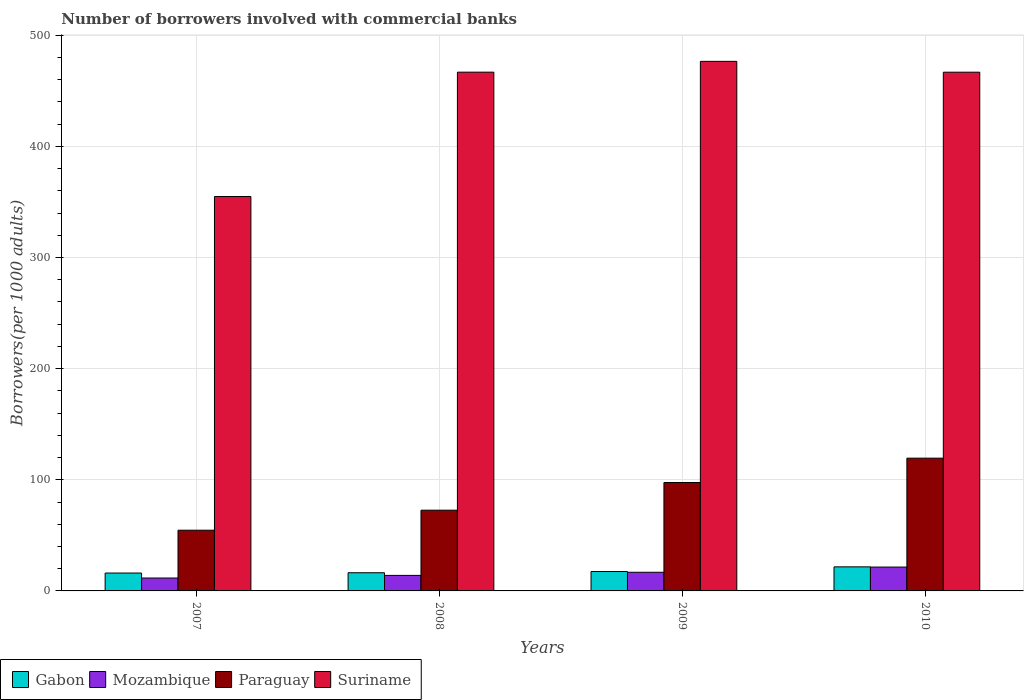How many different coloured bars are there?
Your answer should be compact. 4. Are the number of bars per tick equal to the number of legend labels?
Offer a terse response. Yes. Are the number of bars on each tick of the X-axis equal?
Keep it short and to the point. Yes. How many bars are there on the 4th tick from the right?
Ensure brevity in your answer.  4. What is the label of the 2nd group of bars from the left?
Provide a succinct answer. 2008. In how many cases, is the number of bars for a given year not equal to the number of legend labels?
Offer a terse response. 0. What is the number of borrowers involved with commercial banks in Mozambique in 2010?
Provide a short and direct response. 21.47. Across all years, what is the maximum number of borrowers involved with commercial banks in Gabon?
Offer a terse response. 21.66. Across all years, what is the minimum number of borrowers involved with commercial banks in Gabon?
Your answer should be very brief. 16.09. What is the total number of borrowers involved with commercial banks in Mozambique in the graph?
Ensure brevity in your answer.  63.81. What is the difference between the number of borrowers involved with commercial banks in Gabon in 2008 and that in 2009?
Offer a terse response. -1.11. What is the difference between the number of borrowers involved with commercial banks in Mozambique in 2007 and the number of borrowers involved with commercial banks in Paraguay in 2009?
Your answer should be very brief. -85.94. What is the average number of borrowers involved with commercial banks in Suriname per year?
Provide a succinct answer. 441.21. In the year 2008, what is the difference between the number of borrowers involved with commercial banks in Mozambique and number of borrowers involved with commercial banks in Gabon?
Ensure brevity in your answer.  -2.38. What is the ratio of the number of borrowers involved with commercial banks in Paraguay in 2007 to that in 2010?
Offer a terse response. 0.46. Is the number of borrowers involved with commercial banks in Paraguay in 2009 less than that in 2010?
Provide a succinct answer. Yes. Is the difference between the number of borrowers involved with commercial banks in Mozambique in 2008 and 2010 greater than the difference between the number of borrowers involved with commercial banks in Gabon in 2008 and 2010?
Keep it short and to the point. No. What is the difference between the highest and the second highest number of borrowers involved with commercial banks in Gabon?
Give a very brief answer. 4.2. What is the difference between the highest and the lowest number of borrowers involved with commercial banks in Paraguay?
Give a very brief answer. 64.81. In how many years, is the number of borrowers involved with commercial banks in Paraguay greater than the average number of borrowers involved with commercial banks in Paraguay taken over all years?
Provide a short and direct response. 2. Is it the case that in every year, the sum of the number of borrowers involved with commercial banks in Suriname and number of borrowers involved with commercial banks in Gabon is greater than the sum of number of borrowers involved with commercial banks in Paraguay and number of borrowers involved with commercial banks in Mozambique?
Make the answer very short. Yes. What does the 2nd bar from the left in 2009 represents?
Ensure brevity in your answer.  Mozambique. What does the 1st bar from the right in 2008 represents?
Give a very brief answer. Suriname. Is it the case that in every year, the sum of the number of borrowers involved with commercial banks in Gabon and number of borrowers involved with commercial banks in Paraguay is greater than the number of borrowers involved with commercial banks in Mozambique?
Your response must be concise. Yes. Does the graph contain any zero values?
Provide a short and direct response. No. Where does the legend appear in the graph?
Give a very brief answer. Bottom left. How are the legend labels stacked?
Offer a very short reply. Horizontal. What is the title of the graph?
Your response must be concise. Number of borrowers involved with commercial banks. What is the label or title of the X-axis?
Provide a short and direct response. Years. What is the label or title of the Y-axis?
Provide a short and direct response. Borrowers(per 1000 adults). What is the Borrowers(per 1000 adults) in Gabon in 2007?
Make the answer very short. 16.09. What is the Borrowers(per 1000 adults) of Mozambique in 2007?
Offer a terse response. 11.6. What is the Borrowers(per 1000 adults) of Paraguay in 2007?
Keep it short and to the point. 54.63. What is the Borrowers(per 1000 adults) in Suriname in 2007?
Your answer should be very brief. 354.87. What is the Borrowers(per 1000 adults) in Gabon in 2008?
Offer a very short reply. 16.35. What is the Borrowers(per 1000 adults) in Mozambique in 2008?
Your answer should be compact. 13.97. What is the Borrowers(per 1000 adults) of Paraguay in 2008?
Provide a succinct answer. 72.63. What is the Borrowers(per 1000 adults) in Suriname in 2008?
Keep it short and to the point. 466.75. What is the Borrowers(per 1000 adults) of Gabon in 2009?
Provide a short and direct response. 17.46. What is the Borrowers(per 1000 adults) in Mozambique in 2009?
Your answer should be very brief. 16.77. What is the Borrowers(per 1000 adults) in Paraguay in 2009?
Make the answer very short. 97.54. What is the Borrowers(per 1000 adults) in Suriname in 2009?
Offer a very short reply. 476.48. What is the Borrowers(per 1000 adults) in Gabon in 2010?
Your response must be concise. 21.66. What is the Borrowers(per 1000 adults) of Mozambique in 2010?
Offer a terse response. 21.47. What is the Borrowers(per 1000 adults) in Paraguay in 2010?
Your response must be concise. 119.45. What is the Borrowers(per 1000 adults) of Suriname in 2010?
Your answer should be very brief. 466.73. Across all years, what is the maximum Borrowers(per 1000 adults) of Gabon?
Offer a terse response. 21.66. Across all years, what is the maximum Borrowers(per 1000 adults) in Mozambique?
Offer a terse response. 21.47. Across all years, what is the maximum Borrowers(per 1000 adults) in Paraguay?
Provide a short and direct response. 119.45. Across all years, what is the maximum Borrowers(per 1000 adults) in Suriname?
Your answer should be compact. 476.48. Across all years, what is the minimum Borrowers(per 1000 adults) of Gabon?
Your answer should be compact. 16.09. Across all years, what is the minimum Borrowers(per 1000 adults) of Mozambique?
Offer a very short reply. 11.6. Across all years, what is the minimum Borrowers(per 1000 adults) of Paraguay?
Give a very brief answer. 54.63. Across all years, what is the minimum Borrowers(per 1000 adults) in Suriname?
Offer a terse response. 354.87. What is the total Borrowers(per 1000 adults) in Gabon in the graph?
Your response must be concise. 71.55. What is the total Borrowers(per 1000 adults) of Mozambique in the graph?
Your response must be concise. 63.81. What is the total Borrowers(per 1000 adults) of Paraguay in the graph?
Provide a short and direct response. 344.25. What is the total Borrowers(per 1000 adults) in Suriname in the graph?
Offer a very short reply. 1764.83. What is the difference between the Borrowers(per 1000 adults) of Gabon in 2007 and that in 2008?
Keep it short and to the point. -0.26. What is the difference between the Borrowers(per 1000 adults) in Mozambique in 2007 and that in 2008?
Offer a very short reply. -2.37. What is the difference between the Borrowers(per 1000 adults) of Paraguay in 2007 and that in 2008?
Your answer should be very brief. -18. What is the difference between the Borrowers(per 1000 adults) in Suriname in 2007 and that in 2008?
Your response must be concise. -111.88. What is the difference between the Borrowers(per 1000 adults) in Gabon in 2007 and that in 2009?
Provide a short and direct response. -1.37. What is the difference between the Borrowers(per 1000 adults) of Mozambique in 2007 and that in 2009?
Ensure brevity in your answer.  -5.17. What is the difference between the Borrowers(per 1000 adults) in Paraguay in 2007 and that in 2009?
Your answer should be very brief. -42.91. What is the difference between the Borrowers(per 1000 adults) of Suriname in 2007 and that in 2009?
Provide a short and direct response. -121.61. What is the difference between the Borrowers(per 1000 adults) in Gabon in 2007 and that in 2010?
Give a very brief answer. -5.56. What is the difference between the Borrowers(per 1000 adults) in Mozambique in 2007 and that in 2010?
Provide a short and direct response. -9.87. What is the difference between the Borrowers(per 1000 adults) of Paraguay in 2007 and that in 2010?
Provide a succinct answer. -64.81. What is the difference between the Borrowers(per 1000 adults) of Suriname in 2007 and that in 2010?
Offer a very short reply. -111.86. What is the difference between the Borrowers(per 1000 adults) of Gabon in 2008 and that in 2009?
Provide a succinct answer. -1.11. What is the difference between the Borrowers(per 1000 adults) in Mozambique in 2008 and that in 2009?
Make the answer very short. -2.8. What is the difference between the Borrowers(per 1000 adults) of Paraguay in 2008 and that in 2009?
Keep it short and to the point. -24.9. What is the difference between the Borrowers(per 1000 adults) of Suriname in 2008 and that in 2009?
Offer a very short reply. -9.73. What is the difference between the Borrowers(per 1000 adults) of Gabon in 2008 and that in 2010?
Offer a terse response. -5.3. What is the difference between the Borrowers(per 1000 adults) in Mozambique in 2008 and that in 2010?
Give a very brief answer. -7.5. What is the difference between the Borrowers(per 1000 adults) in Paraguay in 2008 and that in 2010?
Offer a terse response. -46.81. What is the difference between the Borrowers(per 1000 adults) of Suriname in 2008 and that in 2010?
Your response must be concise. 0.03. What is the difference between the Borrowers(per 1000 adults) of Gabon in 2009 and that in 2010?
Ensure brevity in your answer.  -4.2. What is the difference between the Borrowers(per 1000 adults) of Mozambique in 2009 and that in 2010?
Give a very brief answer. -4.7. What is the difference between the Borrowers(per 1000 adults) of Paraguay in 2009 and that in 2010?
Your answer should be very brief. -21.91. What is the difference between the Borrowers(per 1000 adults) in Suriname in 2009 and that in 2010?
Provide a short and direct response. 9.76. What is the difference between the Borrowers(per 1000 adults) of Gabon in 2007 and the Borrowers(per 1000 adults) of Mozambique in 2008?
Make the answer very short. 2.12. What is the difference between the Borrowers(per 1000 adults) of Gabon in 2007 and the Borrowers(per 1000 adults) of Paraguay in 2008?
Provide a short and direct response. -56.54. What is the difference between the Borrowers(per 1000 adults) of Gabon in 2007 and the Borrowers(per 1000 adults) of Suriname in 2008?
Your answer should be compact. -450.66. What is the difference between the Borrowers(per 1000 adults) of Mozambique in 2007 and the Borrowers(per 1000 adults) of Paraguay in 2008?
Keep it short and to the point. -61.03. What is the difference between the Borrowers(per 1000 adults) of Mozambique in 2007 and the Borrowers(per 1000 adults) of Suriname in 2008?
Your answer should be very brief. -455.16. What is the difference between the Borrowers(per 1000 adults) of Paraguay in 2007 and the Borrowers(per 1000 adults) of Suriname in 2008?
Your response must be concise. -412.12. What is the difference between the Borrowers(per 1000 adults) of Gabon in 2007 and the Borrowers(per 1000 adults) of Mozambique in 2009?
Provide a succinct answer. -0.68. What is the difference between the Borrowers(per 1000 adults) of Gabon in 2007 and the Borrowers(per 1000 adults) of Paraguay in 2009?
Ensure brevity in your answer.  -81.45. What is the difference between the Borrowers(per 1000 adults) of Gabon in 2007 and the Borrowers(per 1000 adults) of Suriname in 2009?
Give a very brief answer. -460.39. What is the difference between the Borrowers(per 1000 adults) of Mozambique in 2007 and the Borrowers(per 1000 adults) of Paraguay in 2009?
Your answer should be very brief. -85.94. What is the difference between the Borrowers(per 1000 adults) in Mozambique in 2007 and the Borrowers(per 1000 adults) in Suriname in 2009?
Offer a terse response. -464.89. What is the difference between the Borrowers(per 1000 adults) of Paraguay in 2007 and the Borrowers(per 1000 adults) of Suriname in 2009?
Make the answer very short. -421.85. What is the difference between the Borrowers(per 1000 adults) of Gabon in 2007 and the Borrowers(per 1000 adults) of Mozambique in 2010?
Offer a very short reply. -5.38. What is the difference between the Borrowers(per 1000 adults) of Gabon in 2007 and the Borrowers(per 1000 adults) of Paraguay in 2010?
Your answer should be very brief. -103.35. What is the difference between the Borrowers(per 1000 adults) in Gabon in 2007 and the Borrowers(per 1000 adults) in Suriname in 2010?
Provide a succinct answer. -450.63. What is the difference between the Borrowers(per 1000 adults) of Mozambique in 2007 and the Borrowers(per 1000 adults) of Paraguay in 2010?
Offer a very short reply. -107.85. What is the difference between the Borrowers(per 1000 adults) in Mozambique in 2007 and the Borrowers(per 1000 adults) in Suriname in 2010?
Make the answer very short. -455.13. What is the difference between the Borrowers(per 1000 adults) in Paraguay in 2007 and the Borrowers(per 1000 adults) in Suriname in 2010?
Give a very brief answer. -412.09. What is the difference between the Borrowers(per 1000 adults) of Gabon in 2008 and the Borrowers(per 1000 adults) of Mozambique in 2009?
Your answer should be very brief. -0.42. What is the difference between the Borrowers(per 1000 adults) in Gabon in 2008 and the Borrowers(per 1000 adults) in Paraguay in 2009?
Your answer should be very brief. -81.19. What is the difference between the Borrowers(per 1000 adults) in Gabon in 2008 and the Borrowers(per 1000 adults) in Suriname in 2009?
Ensure brevity in your answer.  -460.13. What is the difference between the Borrowers(per 1000 adults) of Mozambique in 2008 and the Borrowers(per 1000 adults) of Paraguay in 2009?
Provide a short and direct response. -83.57. What is the difference between the Borrowers(per 1000 adults) of Mozambique in 2008 and the Borrowers(per 1000 adults) of Suriname in 2009?
Offer a very short reply. -462.52. What is the difference between the Borrowers(per 1000 adults) of Paraguay in 2008 and the Borrowers(per 1000 adults) of Suriname in 2009?
Keep it short and to the point. -403.85. What is the difference between the Borrowers(per 1000 adults) in Gabon in 2008 and the Borrowers(per 1000 adults) in Mozambique in 2010?
Give a very brief answer. -5.12. What is the difference between the Borrowers(per 1000 adults) in Gabon in 2008 and the Borrowers(per 1000 adults) in Paraguay in 2010?
Ensure brevity in your answer.  -103.09. What is the difference between the Borrowers(per 1000 adults) in Gabon in 2008 and the Borrowers(per 1000 adults) in Suriname in 2010?
Offer a very short reply. -450.37. What is the difference between the Borrowers(per 1000 adults) of Mozambique in 2008 and the Borrowers(per 1000 adults) of Paraguay in 2010?
Offer a terse response. -105.48. What is the difference between the Borrowers(per 1000 adults) in Mozambique in 2008 and the Borrowers(per 1000 adults) in Suriname in 2010?
Make the answer very short. -452.76. What is the difference between the Borrowers(per 1000 adults) of Paraguay in 2008 and the Borrowers(per 1000 adults) of Suriname in 2010?
Ensure brevity in your answer.  -394.09. What is the difference between the Borrowers(per 1000 adults) in Gabon in 2009 and the Borrowers(per 1000 adults) in Mozambique in 2010?
Ensure brevity in your answer.  -4.01. What is the difference between the Borrowers(per 1000 adults) in Gabon in 2009 and the Borrowers(per 1000 adults) in Paraguay in 2010?
Ensure brevity in your answer.  -101.99. What is the difference between the Borrowers(per 1000 adults) of Gabon in 2009 and the Borrowers(per 1000 adults) of Suriname in 2010?
Ensure brevity in your answer.  -449.27. What is the difference between the Borrowers(per 1000 adults) of Mozambique in 2009 and the Borrowers(per 1000 adults) of Paraguay in 2010?
Your answer should be very brief. -102.67. What is the difference between the Borrowers(per 1000 adults) in Mozambique in 2009 and the Borrowers(per 1000 adults) in Suriname in 2010?
Make the answer very short. -449.95. What is the difference between the Borrowers(per 1000 adults) of Paraguay in 2009 and the Borrowers(per 1000 adults) of Suriname in 2010?
Provide a succinct answer. -369.19. What is the average Borrowers(per 1000 adults) of Gabon per year?
Your response must be concise. 17.89. What is the average Borrowers(per 1000 adults) in Mozambique per year?
Provide a short and direct response. 15.95. What is the average Borrowers(per 1000 adults) in Paraguay per year?
Offer a terse response. 86.06. What is the average Borrowers(per 1000 adults) in Suriname per year?
Make the answer very short. 441.21. In the year 2007, what is the difference between the Borrowers(per 1000 adults) of Gabon and Borrowers(per 1000 adults) of Mozambique?
Provide a short and direct response. 4.49. In the year 2007, what is the difference between the Borrowers(per 1000 adults) of Gabon and Borrowers(per 1000 adults) of Paraguay?
Make the answer very short. -38.54. In the year 2007, what is the difference between the Borrowers(per 1000 adults) in Gabon and Borrowers(per 1000 adults) in Suriname?
Your answer should be compact. -338.78. In the year 2007, what is the difference between the Borrowers(per 1000 adults) in Mozambique and Borrowers(per 1000 adults) in Paraguay?
Provide a short and direct response. -43.03. In the year 2007, what is the difference between the Borrowers(per 1000 adults) in Mozambique and Borrowers(per 1000 adults) in Suriname?
Make the answer very short. -343.27. In the year 2007, what is the difference between the Borrowers(per 1000 adults) of Paraguay and Borrowers(per 1000 adults) of Suriname?
Provide a short and direct response. -300.24. In the year 2008, what is the difference between the Borrowers(per 1000 adults) of Gabon and Borrowers(per 1000 adults) of Mozambique?
Provide a succinct answer. 2.38. In the year 2008, what is the difference between the Borrowers(per 1000 adults) in Gabon and Borrowers(per 1000 adults) in Paraguay?
Offer a terse response. -56.28. In the year 2008, what is the difference between the Borrowers(per 1000 adults) of Gabon and Borrowers(per 1000 adults) of Suriname?
Give a very brief answer. -450.4. In the year 2008, what is the difference between the Borrowers(per 1000 adults) of Mozambique and Borrowers(per 1000 adults) of Paraguay?
Provide a succinct answer. -58.66. In the year 2008, what is the difference between the Borrowers(per 1000 adults) of Mozambique and Borrowers(per 1000 adults) of Suriname?
Provide a short and direct response. -452.78. In the year 2008, what is the difference between the Borrowers(per 1000 adults) in Paraguay and Borrowers(per 1000 adults) in Suriname?
Offer a terse response. -394.12. In the year 2009, what is the difference between the Borrowers(per 1000 adults) in Gabon and Borrowers(per 1000 adults) in Mozambique?
Your answer should be very brief. 0.68. In the year 2009, what is the difference between the Borrowers(per 1000 adults) in Gabon and Borrowers(per 1000 adults) in Paraguay?
Provide a short and direct response. -80.08. In the year 2009, what is the difference between the Borrowers(per 1000 adults) of Gabon and Borrowers(per 1000 adults) of Suriname?
Ensure brevity in your answer.  -459.03. In the year 2009, what is the difference between the Borrowers(per 1000 adults) of Mozambique and Borrowers(per 1000 adults) of Paraguay?
Offer a terse response. -80.76. In the year 2009, what is the difference between the Borrowers(per 1000 adults) of Mozambique and Borrowers(per 1000 adults) of Suriname?
Offer a very short reply. -459.71. In the year 2009, what is the difference between the Borrowers(per 1000 adults) in Paraguay and Borrowers(per 1000 adults) in Suriname?
Ensure brevity in your answer.  -378.95. In the year 2010, what is the difference between the Borrowers(per 1000 adults) of Gabon and Borrowers(per 1000 adults) of Mozambique?
Provide a succinct answer. 0.18. In the year 2010, what is the difference between the Borrowers(per 1000 adults) in Gabon and Borrowers(per 1000 adults) in Paraguay?
Offer a terse response. -97.79. In the year 2010, what is the difference between the Borrowers(per 1000 adults) of Gabon and Borrowers(per 1000 adults) of Suriname?
Give a very brief answer. -445.07. In the year 2010, what is the difference between the Borrowers(per 1000 adults) in Mozambique and Borrowers(per 1000 adults) in Paraguay?
Your response must be concise. -97.97. In the year 2010, what is the difference between the Borrowers(per 1000 adults) in Mozambique and Borrowers(per 1000 adults) in Suriname?
Offer a very short reply. -445.25. In the year 2010, what is the difference between the Borrowers(per 1000 adults) in Paraguay and Borrowers(per 1000 adults) in Suriname?
Your response must be concise. -347.28. What is the ratio of the Borrowers(per 1000 adults) in Gabon in 2007 to that in 2008?
Your response must be concise. 0.98. What is the ratio of the Borrowers(per 1000 adults) of Mozambique in 2007 to that in 2008?
Your response must be concise. 0.83. What is the ratio of the Borrowers(per 1000 adults) of Paraguay in 2007 to that in 2008?
Your answer should be very brief. 0.75. What is the ratio of the Borrowers(per 1000 adults) of Suriname in 2007 to that in 2008?
Offer a very short reply. 0.76. What is the ratio of the Borrowers(per 1000 adults) of Gabon in 2007 to that in 2009?
Your answer should be very brief. 0.92. What is the ratio of the Borrowers(per 1000 adults) in Mozambique in 2007 to that in 2009?
Offer a terse response. 0.69. What is the ratio of the Borrowers(per 1000 adults) in Paraguay in 2007 to that in 2009?
Offer a very short reply. 0.56. What is the ratio of the Borrowers(per 1000 adults) in Suriname in 2007 to that in 2009?
Your answer should be compact. 0.74. What is the ratio of the Borrowers(per 1000 adults) in Gabon in 2007 to that in 2010?
Give a very brief answer. 0.74. What is the ratio of the Borrowers(per 1000 adults) in Mozambique in 2007 to that in 2010?
Make the answer very short. 0.54. What is the ratio of the Borrowers(per 1000 adults) of Paraguay in 2007 to that in 2010?
Your answer should be compact. 0.46. What is the ratio of the Borrowers(per 1000 adults) in Suriname in 2007 to that in 2010?
Provide a succinct answer. 0.76. What is the ratio of the Borrowers(per 1000 adults) in Gabon in 2008 to that in 2009?
Provide a succinct answer. 0.94. What is the ratio of the Borrowers(per 1000 adults) of Mozambique in 2008 to that in 2009?
Give a very brief answer. 0.83. What is the ratio of the Borrowers(per 1000 adults) in Paraguay in 2008 to that in 2009?
Ensure brevity in your answer.  0.74. What is the ratio of the Borrowers(per 1000 adults) of Suriname in 2008 to that in 2009?
Your answer should be compact. 0.98. What is the ratio of the Borrowers(per 1000 adults) in Gabon in 2008 to that in 2010?
Offer a very short reply. 0.76. What is the ratio of the Borrowers(per 1000 adults) of Mozambique in 2008 to that in 2010?
Keep it short and to the point. 0.65. What is the ratio of the Borrowers(per 1000 adults) of Paraguay in 2008 to that in 2010?
Keep it short and to the point. 0.61. What is the ratio of the Borrowers(per 1000 adults) in Suriname in 2008 to that in 2010?
Provide a succinct answer. 1. What is the ratio of the Borrowers(per 1000 adults) in Gabon in 2009 to that in 2010?
Give a very brief answer. 0.81. What is the ratio of the Borrowers(per 1000 adults) in Mozambique in 2009 to that in 2010?
Provide a short and direct response. 0.78. What is the ratio of the Borrowers(per 1000 adults) in Paraguay in 2009 to that in 2010?
Provide a short and direct response. 0.82. What is the ratio of the Borrowers(per 1000 adults) in Suriname in 2009 to that in 2010?
Keep it short and to the point. 1.02. What is the difference between the highest and the second highest Borrowers(per 1000 adults) in Gabon?
Your response must be concise. 4.2. What is the difference between the highest and the second highest Borrowers(per 1000 adults) of Mozambique?
Provide a succinct answer. 4.7. What is the difference between the highest and the second highest Borrowers(per 1000 adults) of Paraguay?
Give a very brief answer. 21.91. What is the difference between the highest and the second highest Borrowers(per 1000 adults) in Suriname?
Provide a short and direct response. 9.73. What is the difference between the highest and the lowest Borrowers(per 1000 adults) of Gabon?
Keep it short and to the point. 5.56. What is the difference between the highest and the lowest Borrowers(per 1000 adults) in Mozambique?
Keep it short and to the point. 9.87. What is the difference between the highest and the lowest Borrowers(per 1000 adults) of Paraguay?
Offer a terse response. 64.81. What is the difference between the highest and the lowest Borrowers(per 1000 adults) in Suriname?
Ensure brevity in your answer.  121.61. 